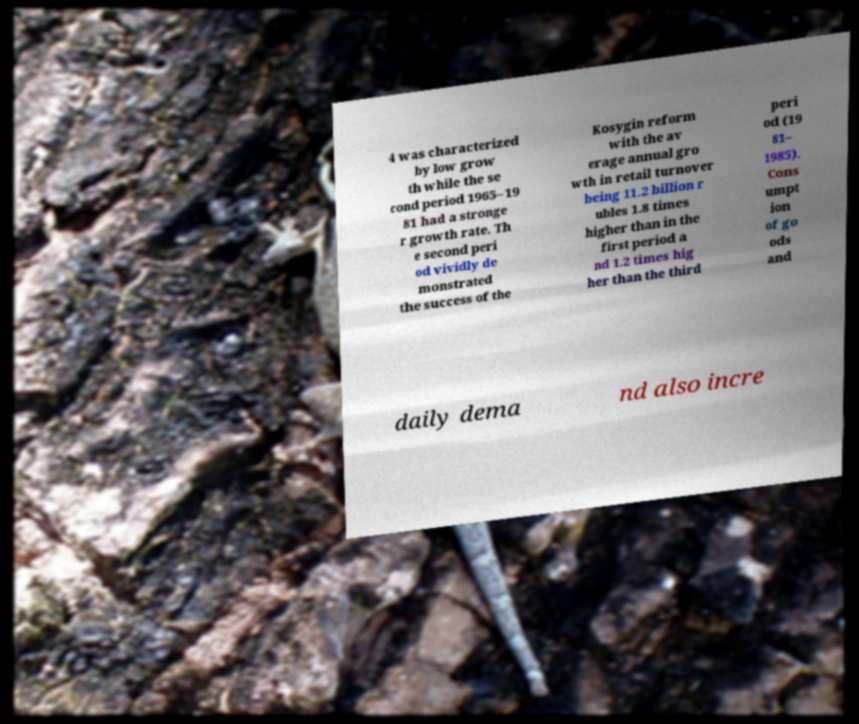Can you accurately transcribe the text from the provided image for me? 4 was characterized by low grow th while the se cond period 1965–19 81 had a stronge r growth rate. Th e second peri od vividly de monstrated the success of the Kosygin reform with the av erage annual gro wth in retail turnover being 11.2 billion r ubles 1.8 times higher than in the first period a nd 1.2 times hig her than the third peri od (19 81– 1985). Cons umpt ion of go ods and daily dema nd also incre 